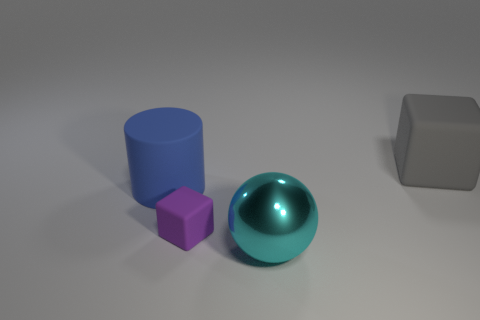Is there any other thing that has the same material as the big cyan ball?
Your response must be concise. No. There is a purple thing that is the same shape as the gray matte thing; what is its material?
Provide a short and direct response. Rubber. How many large objects are either purple spheres or gray objects?
Offer a terse response. 1. Are there fewer blue matte cylinders that are to the left of the cylinder than things that are in front of the small object?
Make the answer very short. Yes. What number of objects are big yellow matte objects or tiny rubber objects?
Your answer should be very brief. 1. There is a rubber cylinder; how many tiny rubber blocks are behind it?
Your response must be concise. 0. What is the shape of the blue object that is the same material as the purple cube?
Give a very brief answer. Cylinder. Is the shape of the big rubber thing right of the big metallic ball the same as  the big blue rubber thing?
Offer a very short reply. No. What number of yellow things are tiny matte cubes or metal spheres?
Your answer should be compact. 0. Is the number of small purple rubber things that are right of the tiny purple thing the same as the number of cyan things on the right side of the big block?
Provide a short and direct response. Yes. 